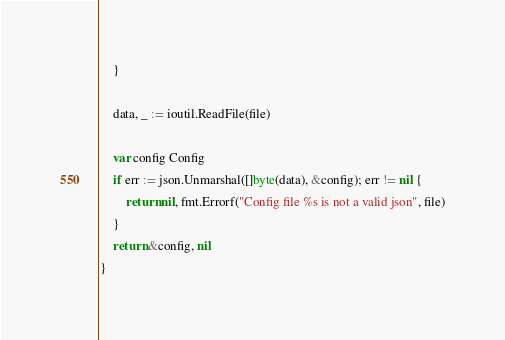Convert code to text. <code><loc_0><loc_0><loc_500><loc_500><_Go_>	}

	data, _ := ioutil.ReadFile(file)

	var config Config
	if err := json.Unmarshal([]byte(data), &config); err != nil {
		return nil, fmt.Errorf("Config file %s is not a valid json", file)
	}
	return &config, nil
}
</code> 